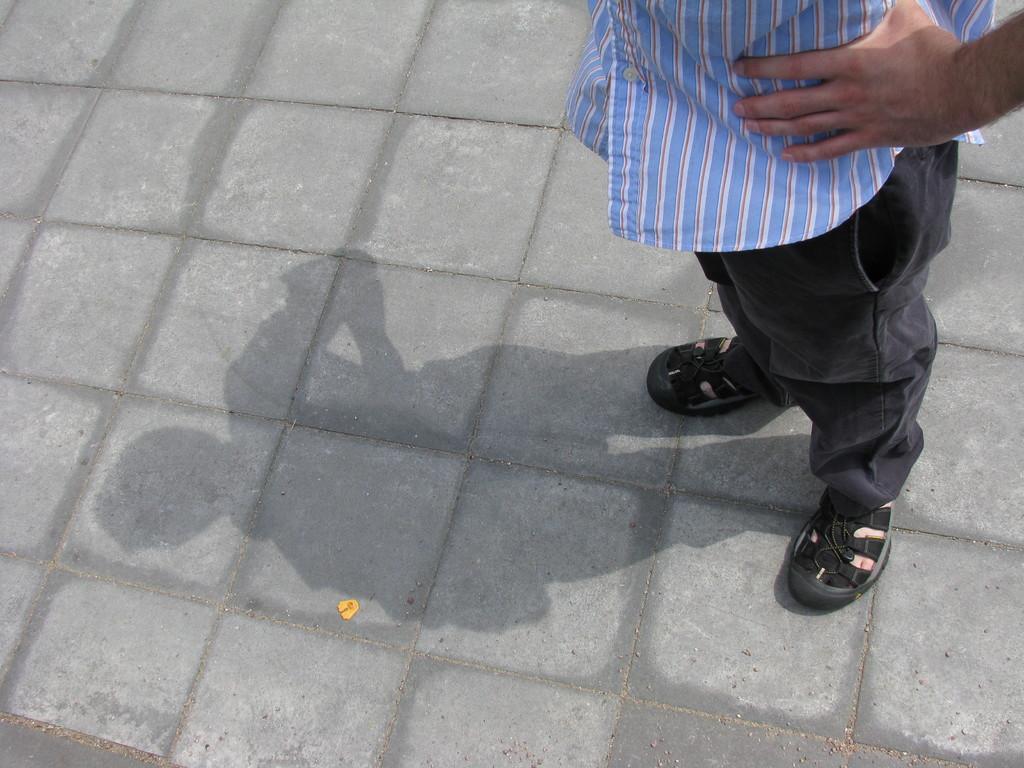In one or two sentences, can you explain what this image depicts? In this image I can see one person is standing and I can also see a shadow on the ground. I can see this person is wearing a blue shirt, and black pant and the black footwear. I can also see a yellow color thing on the ground. 